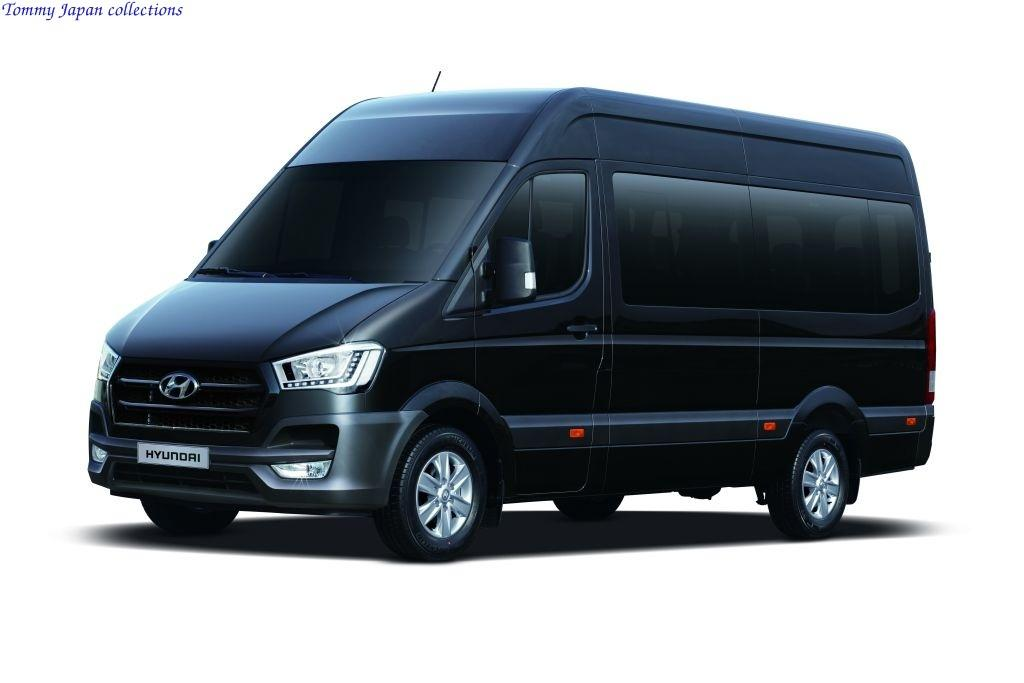<image>
Create a compact narrative representing the image presented. An all-black Hyundai van has darkly tinted windows. 